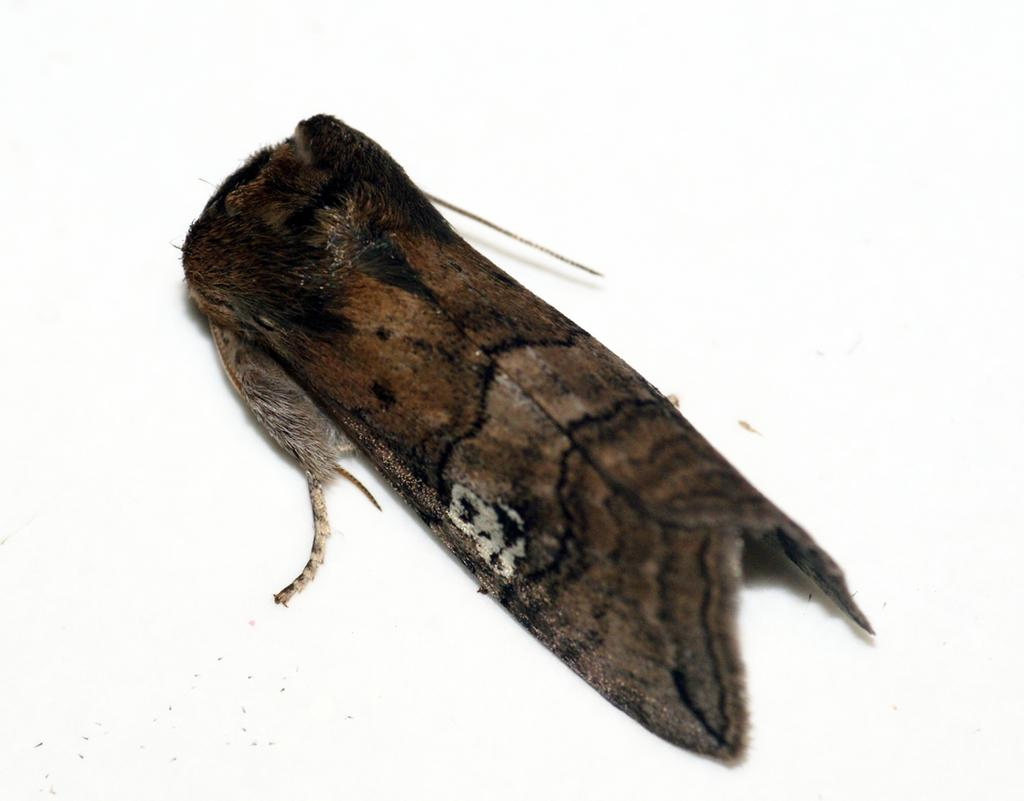What type of creature is present in the image? There is an insect in the image. Can you describe the coloring of the insect? The insect has brown, black, and white coloring. What is the background or surface on which the insect is located? The insect is on a white-colored surface. How many tomatoes are being carried by the pigs in the image? There are no pigs or tomatoes present in the image; it features an insect on a white-colored surface. 